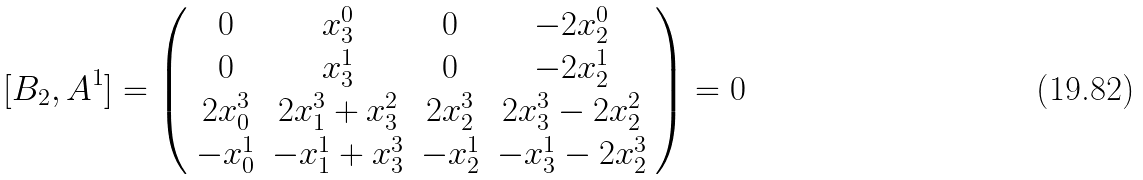<formula> <loc_0><loc_0><loc_500><loc_500>[ B _ { 2 } , A ^ { 1 } ] = \left ( \begin{array} { c c c c } 0 & x ^ { 0 } _ { 3 } & 0 & - 2 x ^ { 0 } _ { 2 } \\ 0 & x ^ { 1 } _ { 3 } & 0 & - 2 x ^ { 1 } _ { 2 } \\ 2 x ^ { 3 } _ { 0 } & 2 x ^ { 3 } _ { 1 } + x ^ { 2 } _ { 3 } & 2 x ^ { 3 } _ { 2 } & 2 x ^ { 3 } _ { 3 } - 2 x ^ { 2 } _ { 2 } \\ - x ^ { 1 } _ { 0 } & - x ^ { 1 } _ { 1 } + x ^ { 3 } _ { 3 } & - x ^ { 1 } _ { 2 } & - x ^ { 1 } _ { 3 } - 2 x ^ { 3 } _ { 2 } \\ \end{array} \right ) = 0</formula> 